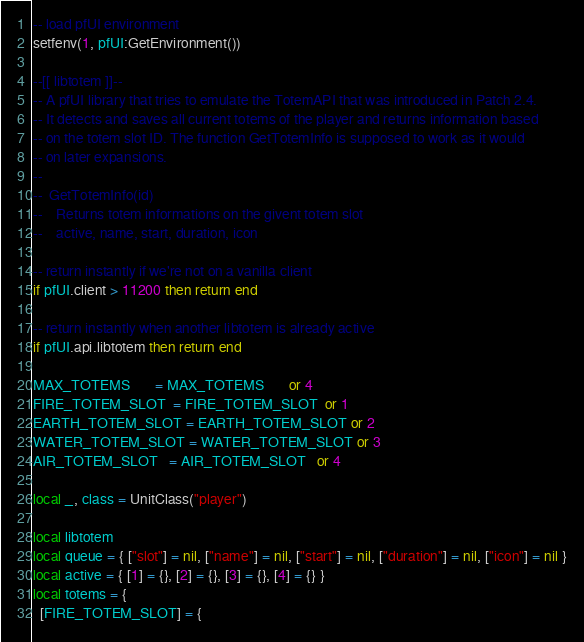<code> <loc_0><loc_0><loc_500><loc_500><_Lua_>-- load pfUI environment
setfenv(1, pfUI:GetEnvironment())

--[[ libtotem ]]--
-- A pfUI library that tries to emulate the TotemAPI that was introduced in Patch 2.4.
-- It detects and saves all current totems of the player and returns information based
-- on the totem slot ID. The function GetTotemInfo is supposed to work as it would
-- on later expansions.
--
--  GetTotemInfo(id)
--    Returns totem informations on the givent totem slot
--    active, name, start, duration, icon

-- return instantly if we're not on a vanilla client
if pfUI.client > 11200 then return end

-- return instantly when another libtotem is already active
if pfUI.api.libtotem then return end

MAX_TOTEMS       = MAX_TOTEMS       or 4
FIRE_TOTEM_SLOT  = FIRE_TOTEM_SLOT  or 1
EARTH_TOTEM_SLOT = EARTH_TOTEM_SLOT or 2
WATER_TOTEM_SLOT = WATER_TOTEM_SLOT or 3
AIR_TOTEM_SLOT   = AIR_TOTEM_SLOT   or 4

local _, class = UnitClass("player")

local libtotem
local queue = { ["slot"] = nil, ["name"] = nil, ["start"] = nil, ["duration"] = nil, ["icon"] = nil }
local active = { [1] = {}, [2] = {}, [3] = {}, [4] = {} }
local totems = {
  [FIRE_TOTEM_SLOT] = {</code> 